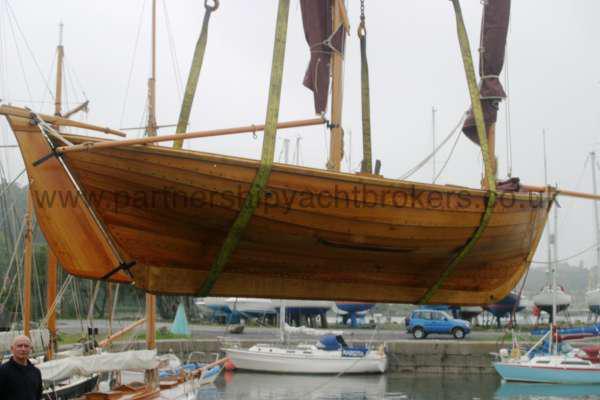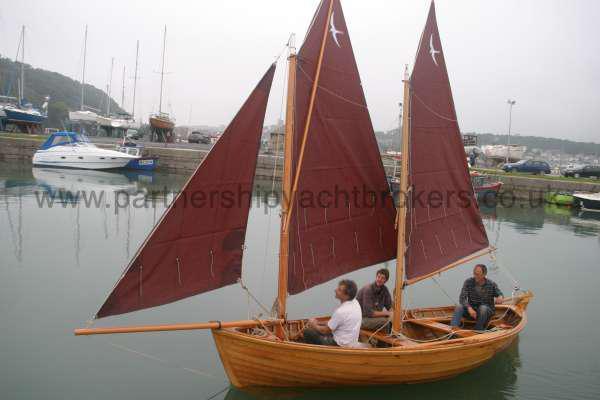The first image is the image on the left, the second image is the image on the right. Assess this claim about the two images: "There is at least three humans riding in a sailboat.". Correct or not? Answer yes or no. Yes. The first image is the image on the left, the second image is the image on the right. Examine the images to the left and right. Is the description "At least three people sit in boats with red sails." accurate? Answer yes or no. Yes. 